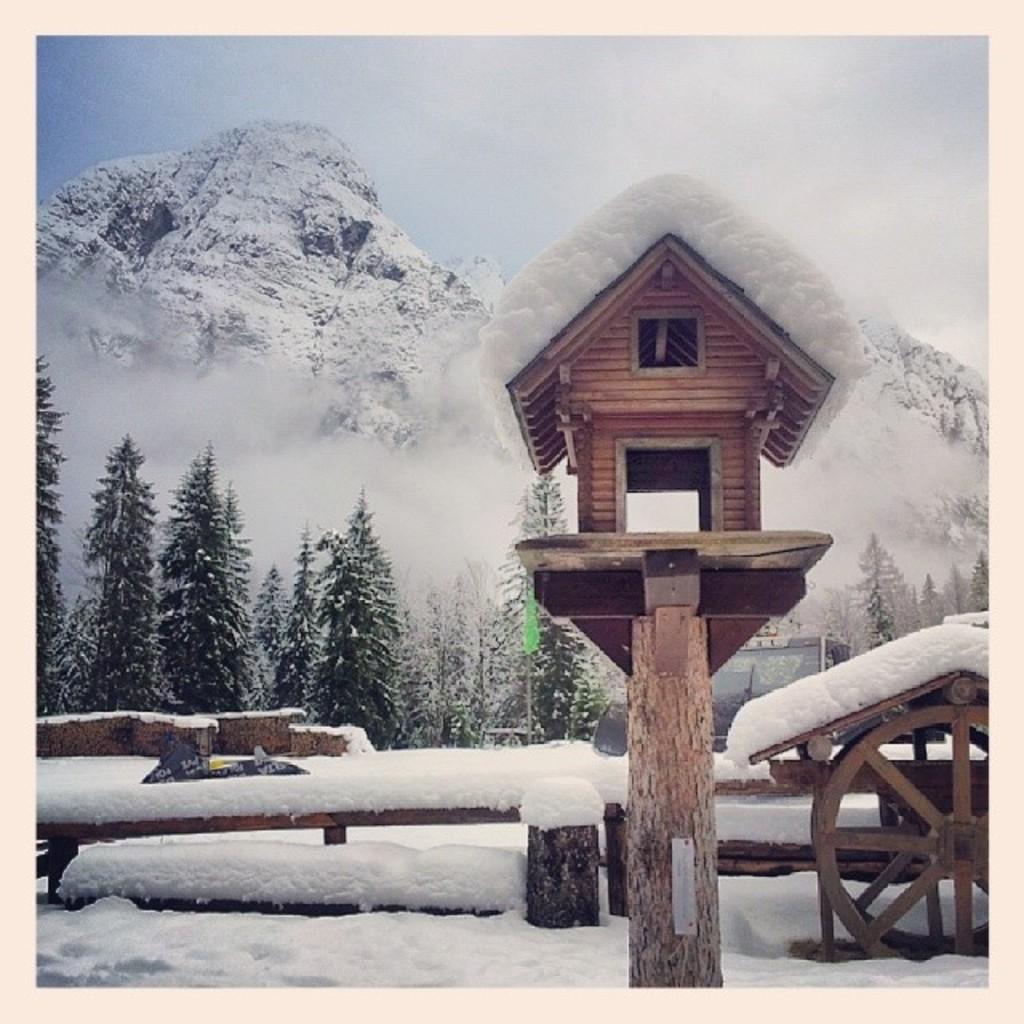Can you describe this image briefly? This is an edited picture. I can see a bird house with a wooden pole, there is snow, there are wooden wheels, there are trees, there are snow mountains, and in the background there is the sky. 